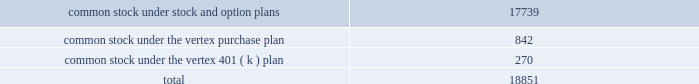"distribution date" ) .
Until the distribution date ( or earlier redemption or expiration of the rights ) , the rights will be traded with , and only with , the common stock .
Until a right is exercised , the right will not entitle the holder thereof to any rights as a stockholder .
If any person or group becomes an acquiring person , each holder of a right , other than rights beneficially owned by the acquiring person , will thereafter have the right to receive upon exercise and payment of the purchase price that number of shares of common stock having a market value of two times the purchase price and , if the company is acquired in a business combination transaction or 50% ( 50 % ) or more of its assets are sold , each holder of a right will thereafter have the right to receive upon exercise and payment of the purchase price that number of shares of common stock of the acquiring company which at the time of the transaction will have a market value of two times the purchase price .
At any time after any person becomes an acquiring person and prior to the acquisition by such person or group of 50% ( 50 % ) or more of the outstanding common stock , the board of directors of the company may cause the rights ( other than rights owned by such person or group ) to be exchanged , in whole or in part , for common stock or junior preferred shares , at an exchange rate of one share of common stock per right or one half of one-hundredth of a junior preferred share per right .
At any time prior to the acquisition by a person or group of beneficial ownership of 15% ( 15 % ) or more of the outstanding common stock , the board of directors of the company may redeem the rights at a price of $ 0.01 per right .
The rights have certain anti-takeover effects , in that they will cause substantial dilution to a person or group that attempts to acquire a significant interest in vertex on terms not approved by the board of directors .
Common stock reserved for future issuance at december 31 , 2005 , the company has reserved shares of common stock for future issuance under all equity compensation plans as follows ( shares in thousands ) : o .
Significant revenue arrangements the company has formed strategic collaborations with pharmaceutical companies and other organizations in the areas of drug discovery , development , and commercialization .
Research , development and commercialization agreements provide the company with financial support and other valuable resources for its research programs and for the development of clinical drug candidates , and the marketing and sales of products .
Collaborative research , development and commercialization agreements in the company's collaborative research , development and commercialization programs the company seeks to discover , develop and commercialize pharmaceutical products in conjunction with and supported by the company's collaborators .
Collaborative research and development arrangements may provide research funding over an initial contract period with renewal and termination options that .

What percent of the total common stock is under the vertex purchase plan? 
Computations: (842 / 18851)
Answer: 0.04467. 